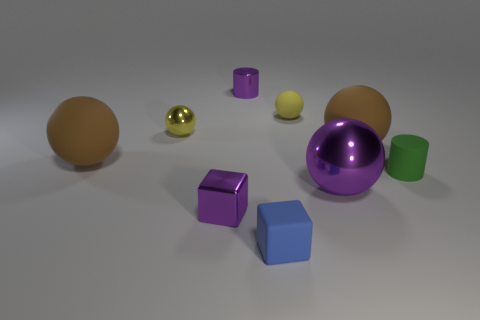Subtract all blue cubes. How many yellow balls are left? 2 Subtract all small yellow matte balls. How many balls are left? 4 Subtract all brown spheres. How many spheres are left? 3 Subtract all cylinders. How many objects are left? 7 Subtract all gray spheres. Subtract all red blocks. How many spheres are left? 5 Add 1 small purple metal objects. How many small purple metal objects are left? 3 Add 7 tiny gray rubber balls. How many tiny gray rubber balls exist? 7 Subtract 0 yellow cubes. How many objects are left? 9 Subtract all green blocks. Subtract all brown matte things. How many objects are left? 7 